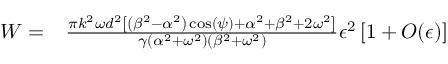<formula> <loc_0><loc_0><loc_500><loc_500>\begin{array} { r l } { W = } & \frac { \pi k ^ { 2 } \omega d ^ { 2 } \left [ \left ( \beta ^ { 2 } - \alpha ^ { 2 } \right ) \cos ( \psi ) + \alpha ^ { 2 } + \beta ^ { 2 } + 2 \omega ^ { 2 } \right ] } { \gamma \left ( \alpha ^ { 2 } + \omega ^ { 2 } \right ) \left ( \beta ^ { 2 } + \omega ^ { 2 } \right ) } \epsilon ^ { 2 } \left [ 1 + O ( \epsilon ) \right ] } \end{array}</formula> 